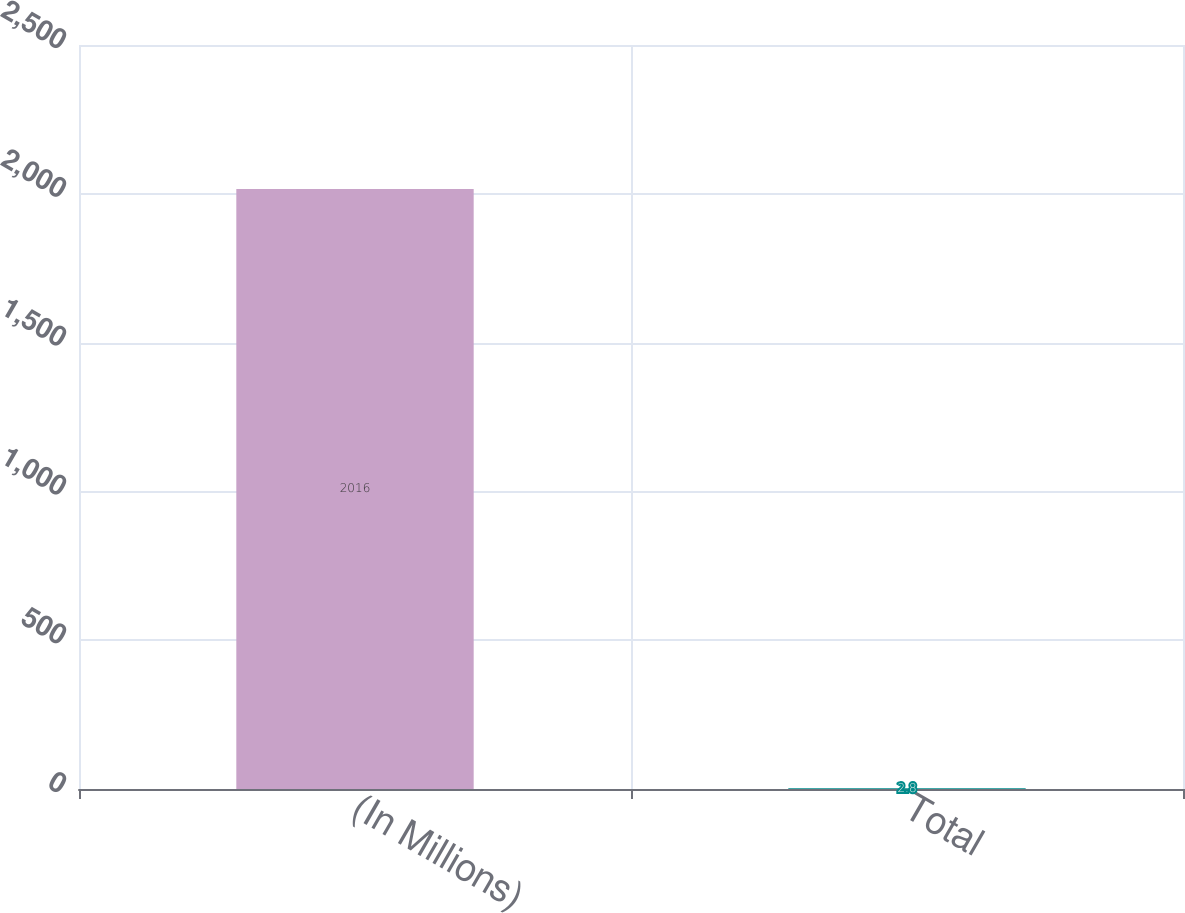<chart> <loc_0><loc_0><loc_500><loc_500><bar_chart><fcel>(In Millions)<fcel>Total<nl><fcel>2016<fcel>2.8<nl></chart> 